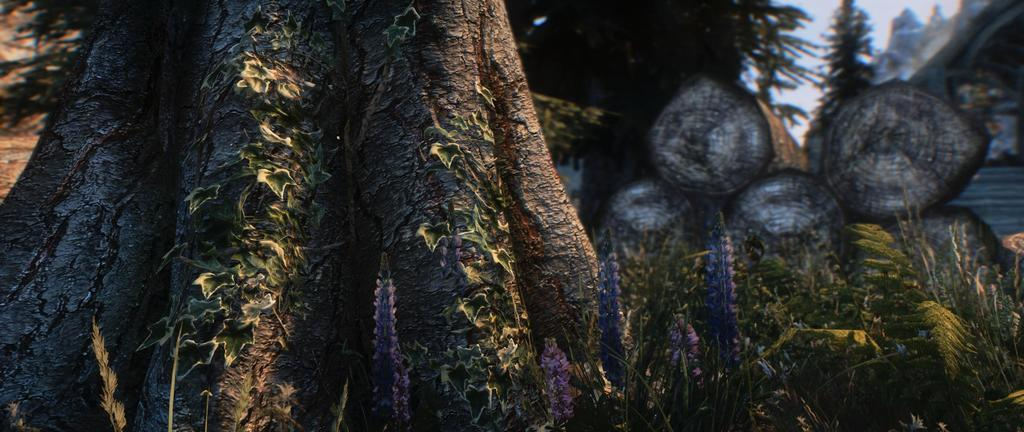What is located in the center of the image? There are trees in the center of the image. What can be seen on the right side of the image? There are logs on the right side of the image. What is visible in the background of the image? The sky is visible in the background of the image. What type of religion is practiced by the grandmother in the image? There is no grandmother present in the image, and therefore no religious practices can be observed. How many snakes are visible in the image? There are no snakes present in the image. 